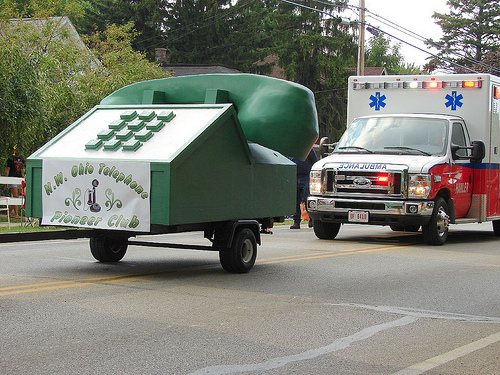<image>
Is there a telephone float behind the ambulance? No. The telephone float is not behind the ambulance. From this viewpoint, the telephone float appears to be positioned elsewhere in the scene. Where is the telephone in relation to the ambulance? Is it in front of the ambulance? Yes. The telephone is positioned in front of the ambulance, appearing closer to the camera viewpoint. 